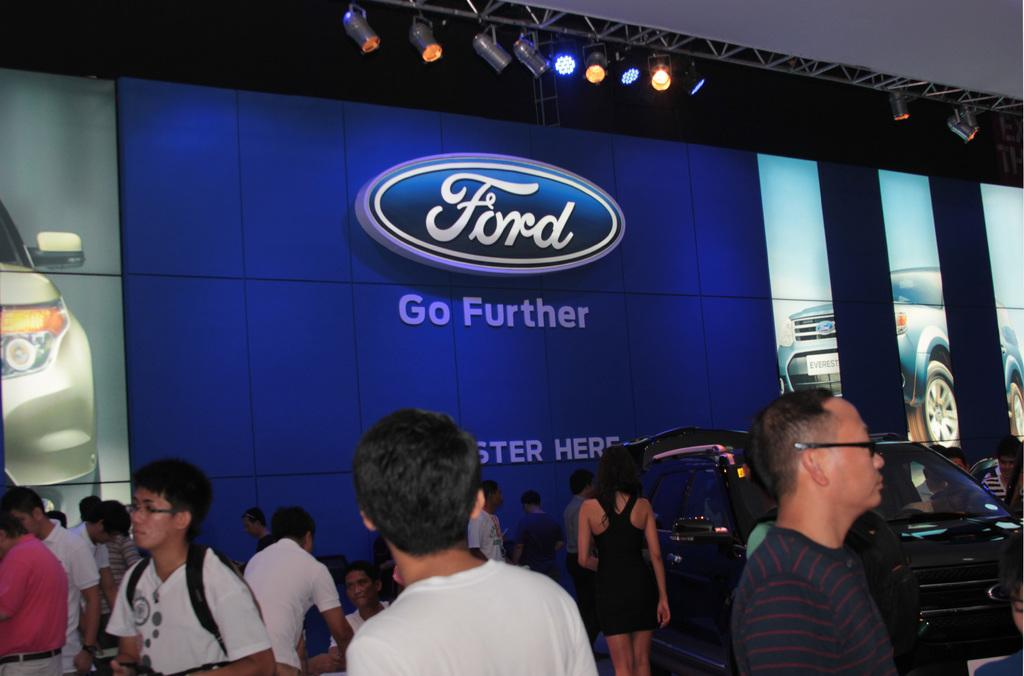How many people are in the group visible in the image? There is a group of people standing in the image, but the exact number cannot be determined from the provided facts. What type of vehicle is in the image? There is a car in the image. What are the focus lights used for in the image? Focus lights are present in the image, but their specific purpose cannot be determined from the provided facts. What is the lighting truss used for in the image? The lighting truss is visible in the image, but its specific purpose cannot be determined from the provided facts. What is the board used for in the image? There is a board in the image, but its specific purpose cannot be determined from the provided facts. What type of butter is being used to write on the board in the image? There is no butter present in the image, and therefore no such activity can be observed. 